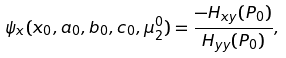Convert formula to latex. <formula><loc_0><loc_0><loc_500><loc_500>\psi _ { x } ( x _ { 0 } , a _ { 0 } , b _ { 0 } , c _ { 0 } , \mu _ { 2 } ^ { 0 } ) = \frac { - H _ { x y } ( P _ { 0 } ) } { H _ { y y } ( P _ { 0 } ) } ,</formula> 